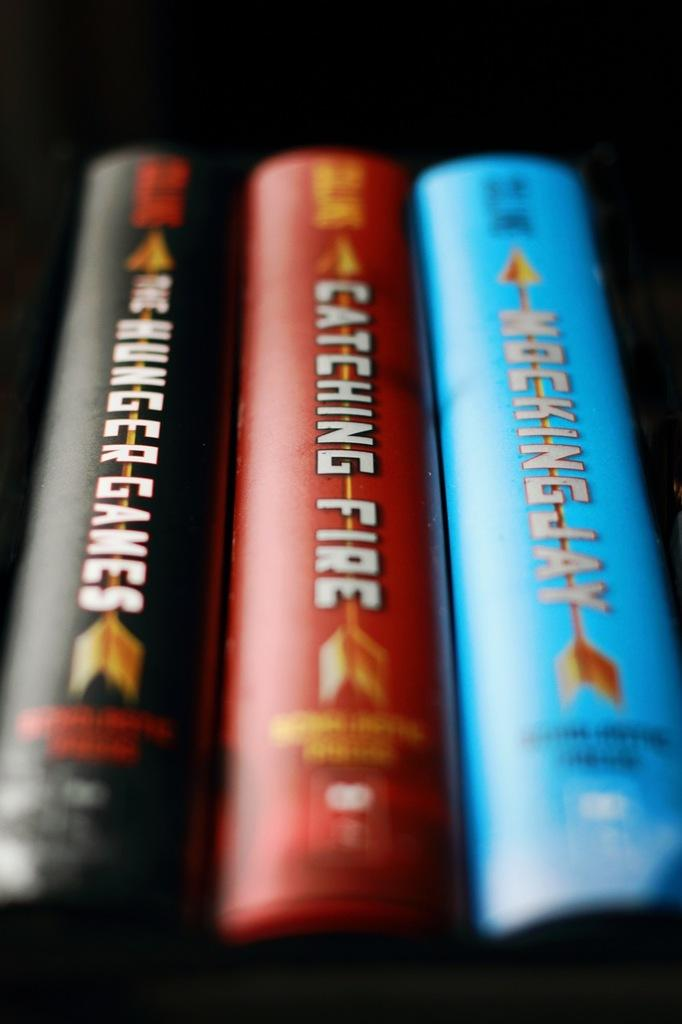Provide a one-sentence caption for the provided image. The Hunger Games, Catching Fire, and Mockingjay are the title of the three novels. 